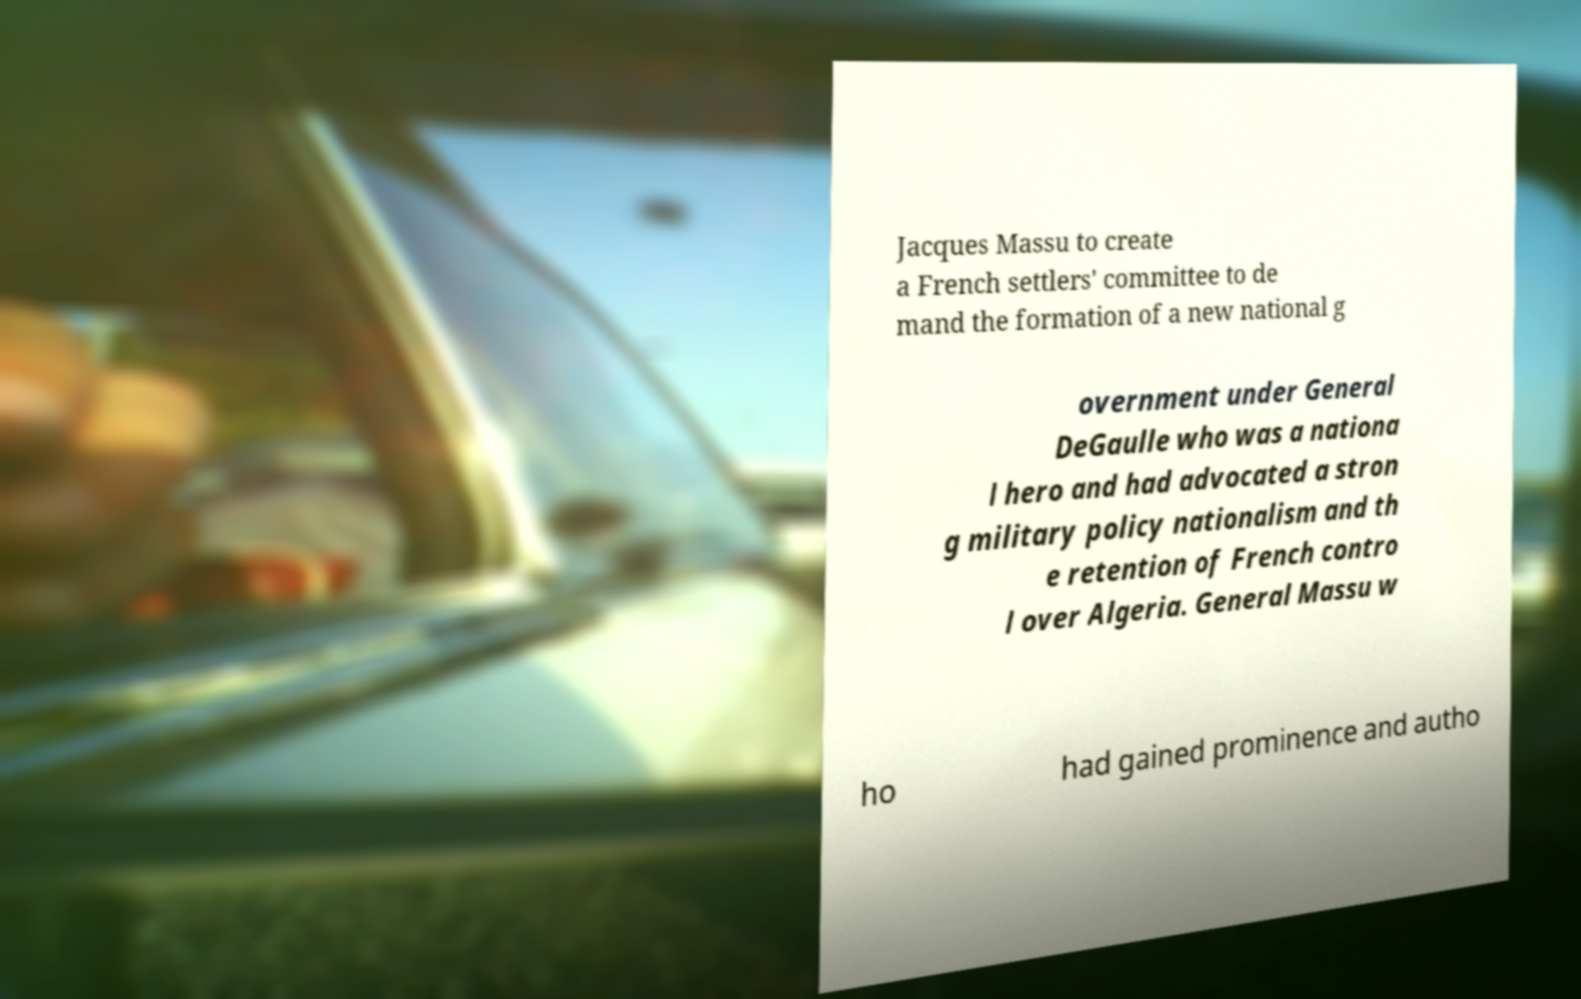For documentation purposes, I need the text within this image transcribed. Could you provide that? Jacques Massu to create a French settlers' committee to de mand the formation of a new national g overnment under General DeGaulle who was a nationa l hero and had advocated a stron g military policy nationalism and th e retention of French contro l over Algeria. General Massu w ho had gained prominence and autho 